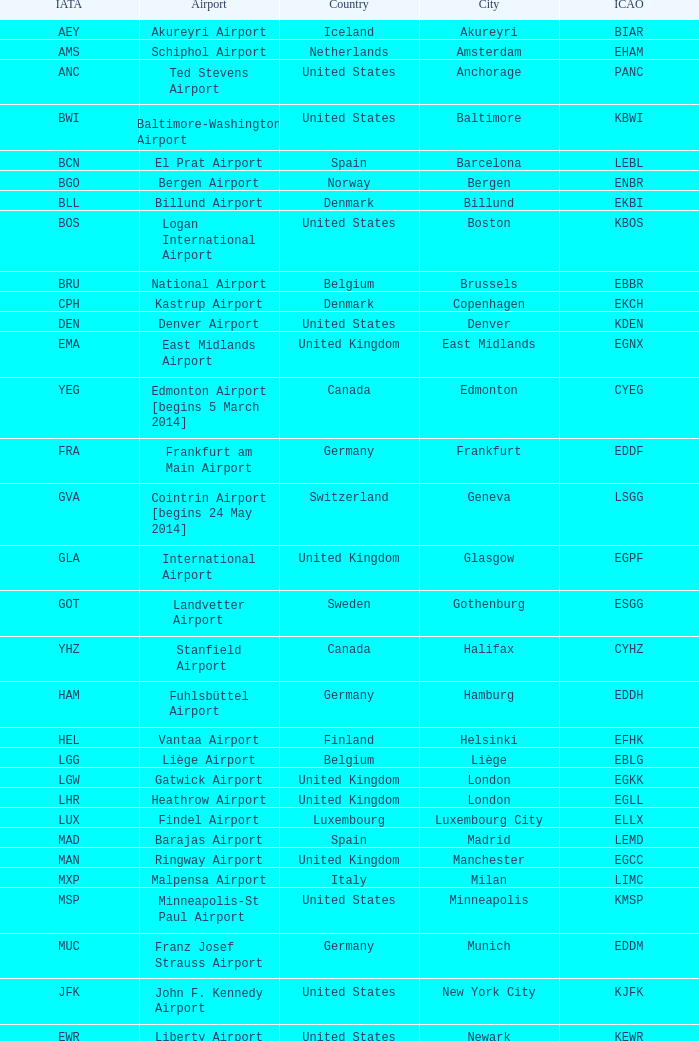What is the Airport with a ICAO of EDDH? Fuhlsbüttel Airport. Can you give me this table as a dict? {'header': ['IATA', 'Airport', 'Country', 'City', 'ICAO'], 'rows': [['AEY', 'Akureyri Airport', 'Iceland', 'Akureyri', 'BIAR'], ['AMS', 'Schiphol Airport', 'Netherlands', 'Amsterdam', 'EHAM'], ['ANC', 'Ted Stevens Airport', 'United States', 'Anchorage', 'PANC'], ['BWI', 'Baltimore-Washington Airport', 'United States', 'Baltimore', 'KBWI'], ['BCN', 'El Prat Airport', 'Spain', 'Barcelona', 'LEBL'], ['BGO', 'Bergen Airport', 'Norway', 'Bergen', 'ENBR'], ['BLL', 'Billund Airport', 'Denmark', 'Billund', 'EKBI'], ['BOS', 'Logan International Airport', 'United States', 'Boston', 'KBOS'], ['BRU', 'National Airport', 'Belgium', 'Brussels', 'EBBR'], ['CPH', 'Kastrup Airport', 'Denmark', 'Copenhagen', 'EKCH'], ['DEN', 'Denver Airport', 'United States', 'Denver', 'KDEN'], ['EMA', 'East Midlands Airport', 'United Kingdom', 'East Midlands', 'EGNX'], ['YEG', 'Edmonton Airport [begins 5 March 2014]', 'Canada', 'Edmonton', 'CYEG'], ['FRA', 'Frankfurt am Main Airport', 'Germany', 'Frankfurt', 'EDDF'], ['GVA', 'Cointrin Airport [begins 24 May 2014]', 'Switzerland', 'Geneva', 'LSGG'], ['GLA', 'International Airport', 'United Kingdom', 'Glasgow', 'EGPF'], ['GOT', 'Landvetter Airport', 'Sweden', 'Gothenburg', 'ESGG'], ['YHZ', 'Stanfield Airport', 'Canada', 'Halifax', 'CYHZ'], ['HAM', 'Fuhlsbüttel Airport', 'Germany', 'Hamburg', 'EDDH'], ['HEL', 'Vantaa Airport', 'Finland', 'Helsinki', 'EFHK'], ['LGG', 'Liège Airport', 'Belgium', 'Liège', 'EBLG'], ['LGW', 'Gatwick Airport', 'United Kingdom', 'London', 'EGKK'], ['LHR', 'Heathrow Airport', 'United Kingdom', 'London', 'EGLL'], ['LUX', 'Findel Airport', 'Luxembourg', 'Luxembourg City', 'ELLX'], ['MAD', 'Barajas Airport', 'Spain', 'Madrid', 'LEMD'], ['MAN', 'Ringway Airport', 'United Kingdom', 'Manchester', 'EGCC'], ['MXP', 'Malpensa Airport', 'Italy', 'Milan', 'LIMC'], ['MSP', 'Minneapolis-St Paul Airport', 'United States', 'Minneapolis', 'KMSP'], ['MUC', 'Franz Josef Strauss Airport', 'Germany', 'Munich', 'EDDM'], ['JFK', 'John F. Kennedy Airport', 'United States', 'New York City', 'KJFK'], ['EWR', 'Liberty Airport', 'United States', 'Newark', 'KEWR'], ['MCO', 'Orlando Airport', 'United States', 'Orlando', 'KMCO'], ['SFB', 'Sanford Airport', 'United States', 'Orlando', 'KSFB'], ['OSL', 'Gardermoen Airport', 'Norway', 'Oslo', 'ENGM'], ['CDG', 'Charles de Gaulle Airport', 'France', 'Paris', 'LFPG'], ['KEF', 'Keflavik Airport', 'Iceland', 'Reykjavík', 'BIKF'], ['LED', 'Pulkovo Airport', 'Russia', 'Saint Petersburg', 'ULLI'], ['SFO', 'San Francisco Airport', 'United States', 'San Francisco', 'KSFO'], ['SEA', 'Seattle–Tacoma Airport', 'United States', 'Seattle', 'KSEA'], ['SVG', 'Sola Airport', 'Norway', 'Stavanger', 'ENZV'], ['ARN', 'Arlanda Airport', 'Sweden', 'Stockholm', 'ESSA'], ['YYZ', 'Pearson Airport', 'Canada', 'Toronto', 'CYYZ'], ['TRD', 'Trondheim Airport', 'Norway', 'Trondheim', 'ENVA'], ['YVR', 'Vancouver Airport [begins 13 May 2014]', 'Canada', 'Vancouver', 'CYVR'], ['IAD', 'Dulles Airport', 'United States', 'Washington, D.C.', 'KIAD'], ['ZRH', 'Kloten Airport', 'Switzerland', 'Zurich', 'LSZH']]} 